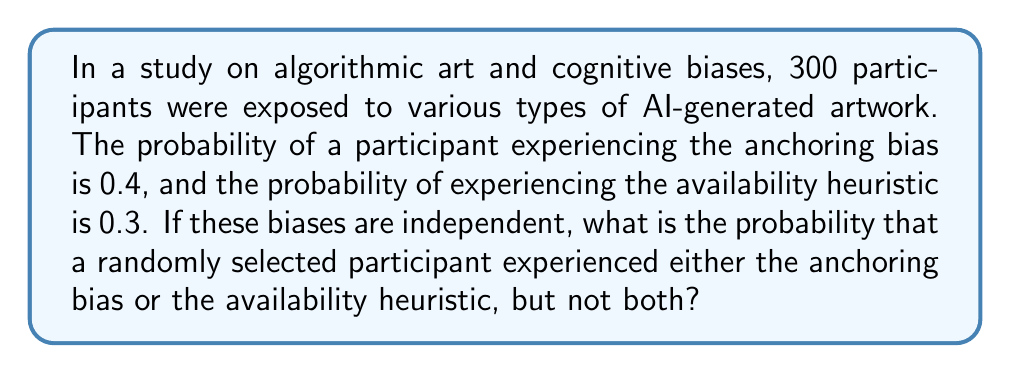Could you help me with this problem? To solve this problem, we'll use the concept of probability for mutually exclusive events and the addition rule for independent events.

Step 1: Define the events
Let A = event of experiencing anchoring bias
Let B = event of experiencing availability heuristic

Step 2: Given probabilities
P(A) = 0.4
P(B) = 0.3

Step 3: Calculate the probability of experiencing both biases
Since the events are independent:
P(A and B) = P(A) × P(B) = 0.4 × 0.3 = 0.12

Step 4: Calculate the probability of experiencing either bias
P(A or B) = P(A) + P(B) - P(A and B)
P(A or B) = 0.4 + 0.3 - 0.12 = 0.58

Step 5: Calculate the probability of experiencing either bias but not both
This is the probability of experiencing either bias minus the probability of experiencing both:
P(either but not both) = P(A or B) - P(A and B)
P(either but not both) = 0.58 - 0.12 = 0.46

Therefore, the probability that a randomly selected participant experienced either the anchoring bias or the availability heuristic, but not both, is 0.46 or 46%.
Answer: 0.46 